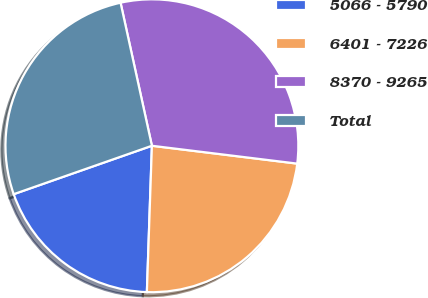Convert chart to OTSL. <chart><loc_0><loc_0><loc_500><loc_500><pie_chart><fcel>5066 - 5790<fcel>6401 - 7226<fcel>8370 - 9265<fcel>Total<nl><fcel>19.09%<fcel>23.6%<fcel>30.38%<fcel>26.93%<nl></chart> 